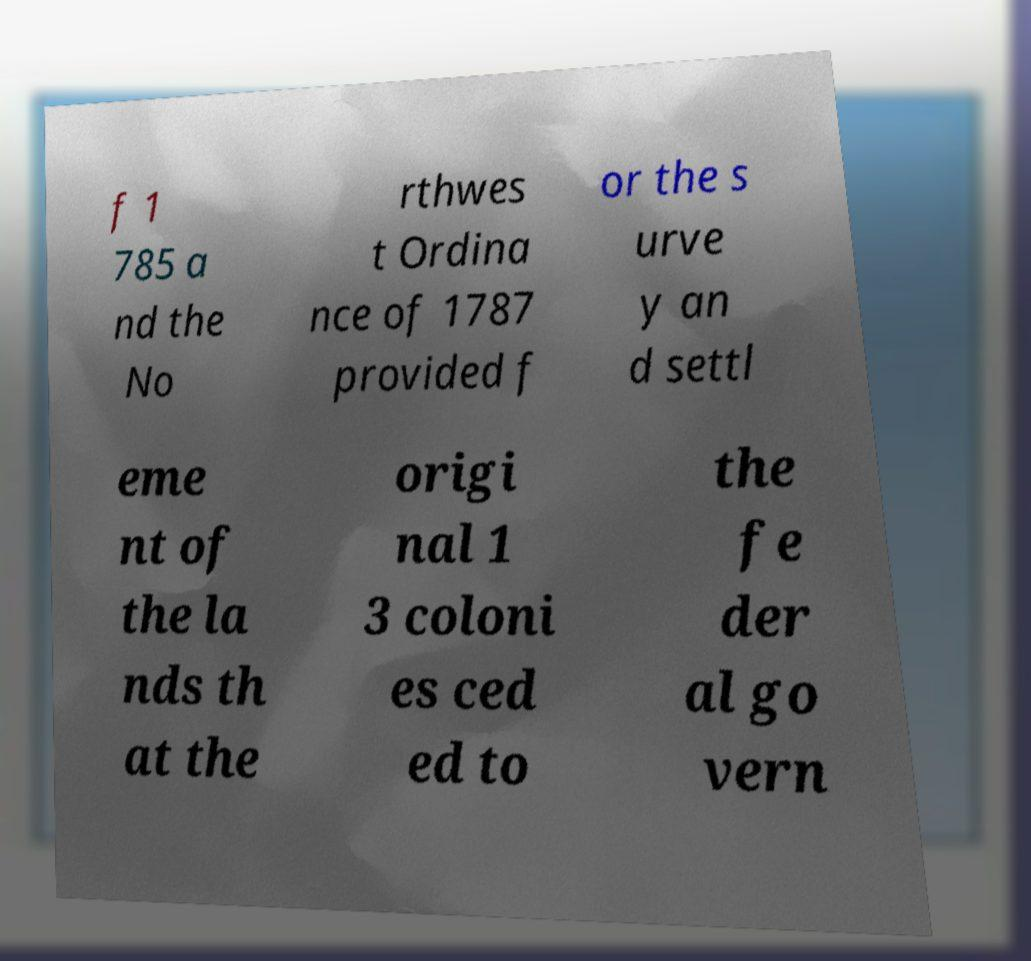Please read and relay the text visible in this image. What does it say? f 1 785 a nd the No rthwes t Ordina nce of 1787 provided f or the s urve y an d settl eme nt of the la nds th at the origi nal 1 3 coloni es ced ed to the fe der al go vern 